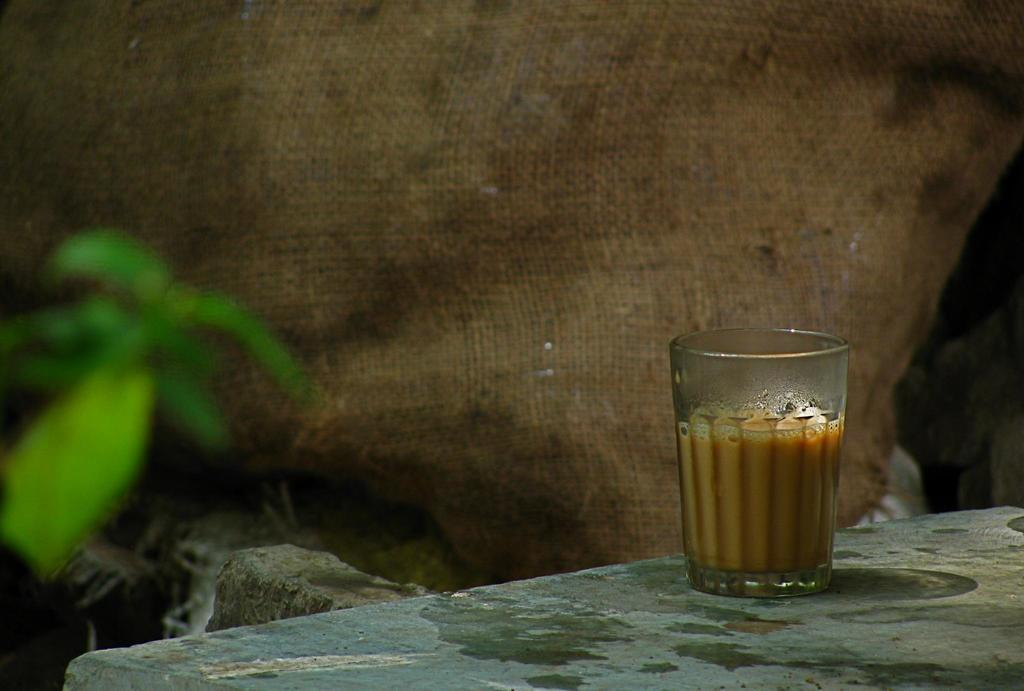What is inside the glass that is visible in the image? There is a brown liquid in the glass in the image. What type of plant can be seen in the image? There is a green plant in the image. What is the color and material of the bag in the image? There is a brown gunny bag in the image. How many points does the fifth development in the image have? There is no reference to a development or points in the image, as it features a glass with brown liquid, a green plant, and a brown gunny bag. 